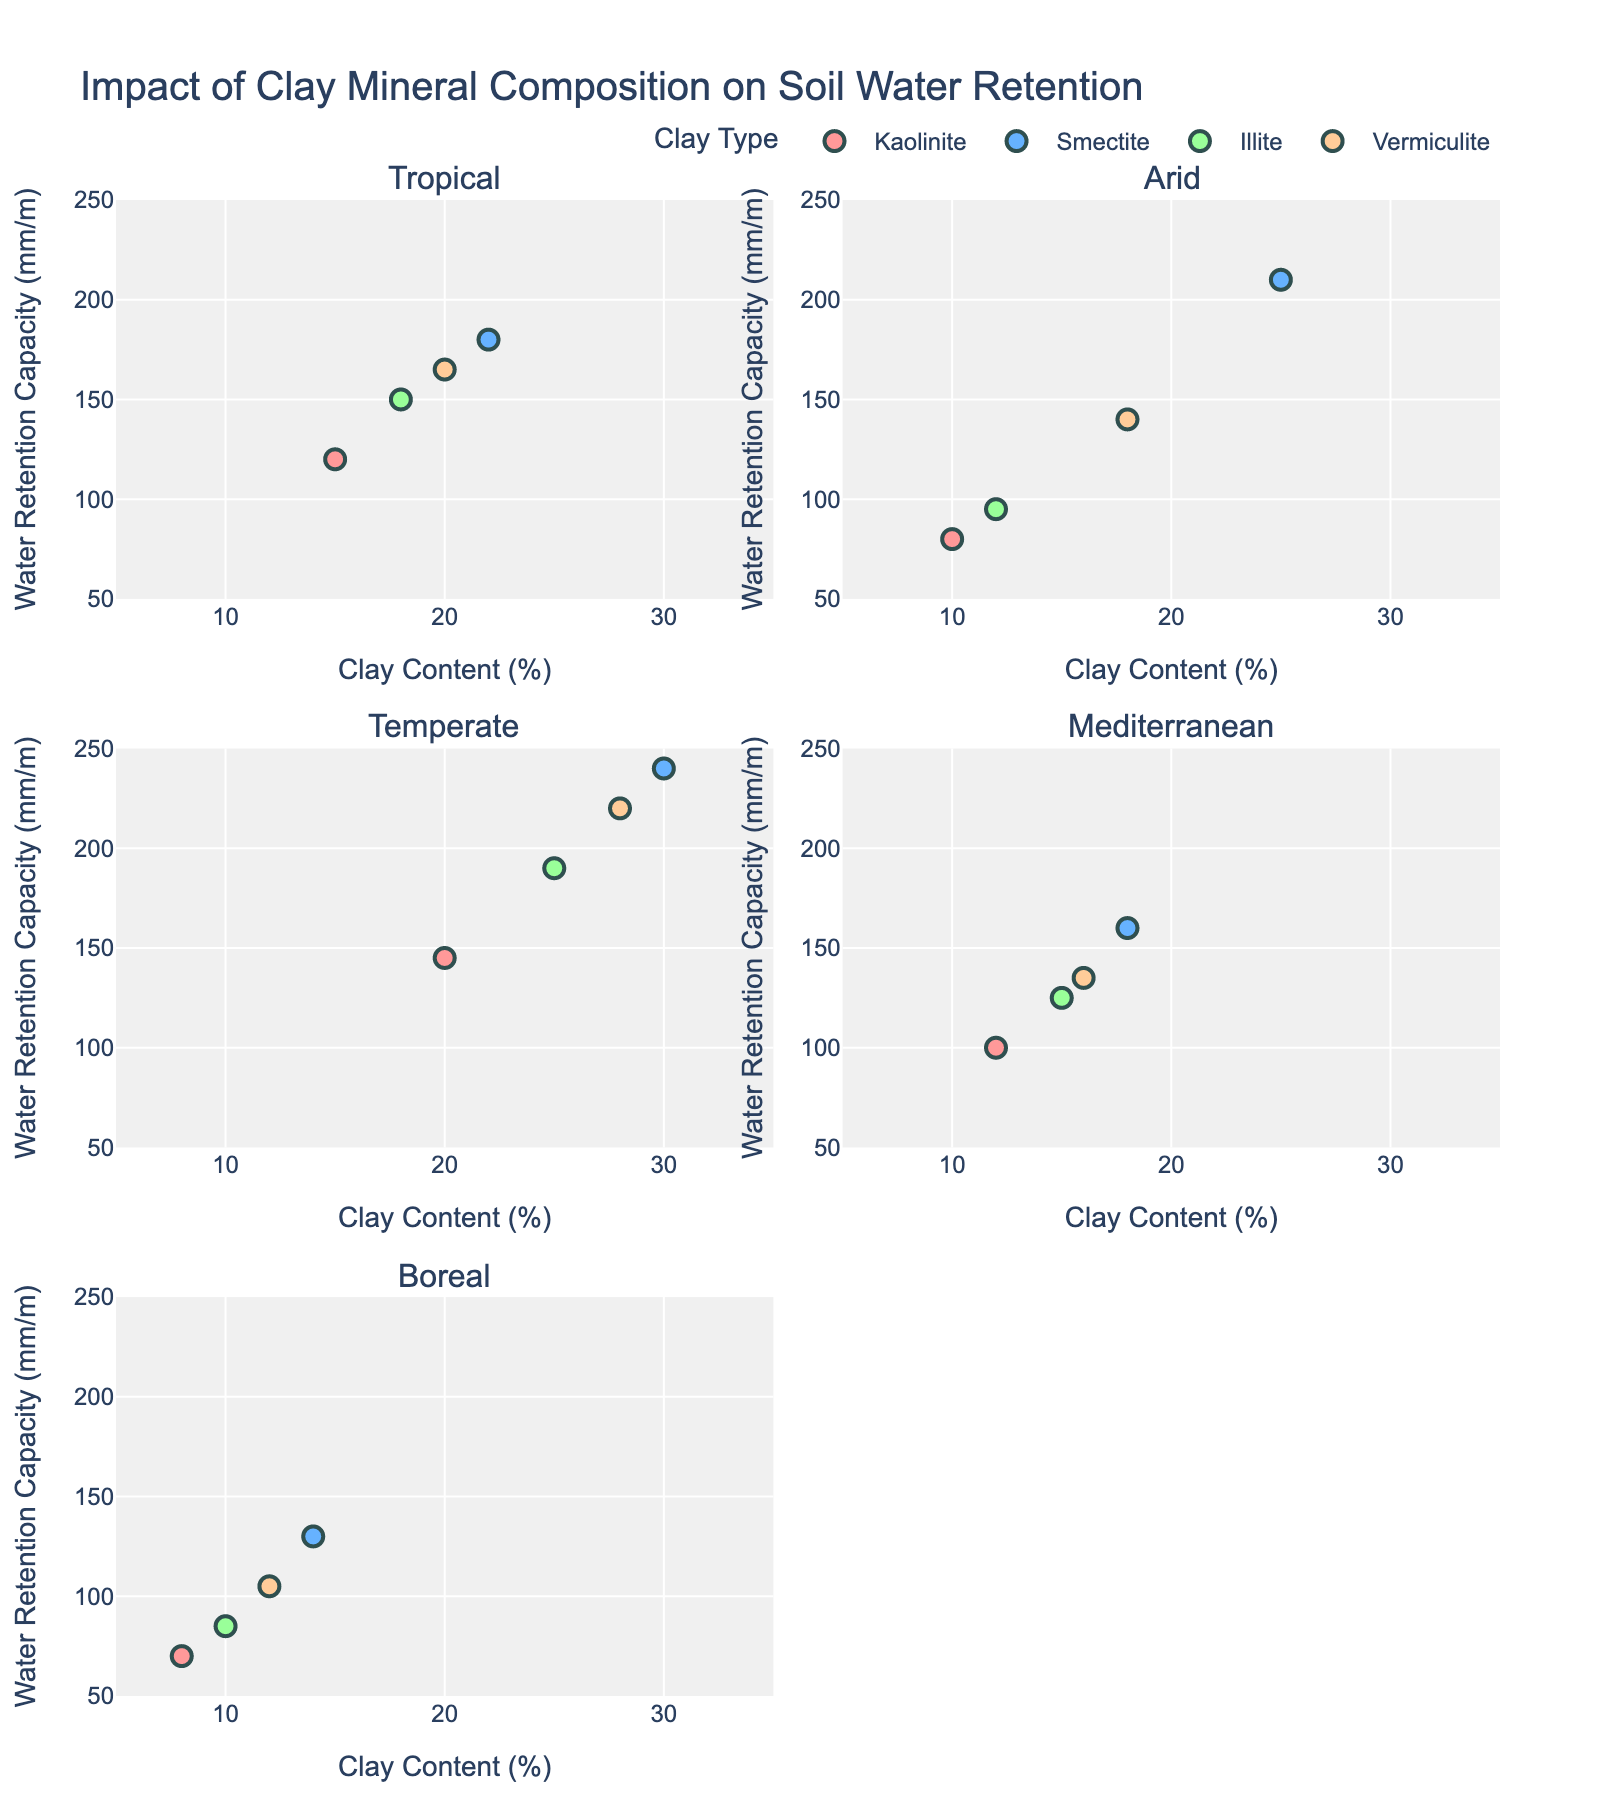What is the title of the figure? The title is written at the top of the figure and summarizes the main topic of the plot. It states "Impact of Clay Mineral Composition on Soil Water Retention."
Answer: Impact of Clay Mineral Composition on Soil Water Retention Which clay type has the highest water retention capacity in the Temperate climate zone? Locate the subplot corresponding to the Temperate climate zone by checking the subplot titles. Observe the scatter plot points, and identify the highest point on the y-axis (Water Retention Capacity) and note its corresponding clay type.
Answer: Smectite How does the water retention capacity for Illite in the Arid zone compare to that in the Tropical zone? Look at the subplots for both the Arid and Tropical zones. Identify the points for Illite in both subplots. Analyze the water retention capacity values (y-axis) for these points. The capacity for Illite in the Arid zone is lower compared to the Tropical zone.
Answer: Lower What is the range of clay content (%) for Kaolinite across all climate zones? Identify all points representing Kaolinite across the subplots. Note the lowest and highest values on the x-axis (Clay Content). The range spans from the minimum to the maximum clay content observed.
Answer: 8-20% Which climate zone has the widest range of water retention capacity for Vermiculite? For each subplot, identify all points representing Vermiculite. Calculate the range by subtracting the minimum y-value from the maximum y-value for Vermiculite in each climate zone. The Temperate zone has the widest range (105).
Answer: Temperate What is the average clay content (%) for Smectite in the Tropical climate zone? Locate the subplot for the Tropical zone and look for points representing Smectite. Sum the clay content values and divide by the number of Smectite points to find the average. The values are 22%, and the average is (22)/1 = 22.
Answer: 22% Which clay type in the Mediterranean climate zone has the lowest water retention capacity? Locate the subplot for the Mediterranean zone. Identify the clay type associated with the lowest point on the y-axis (Water Retention Capacity).
Answer: Kaolinite How does the water retention capacity of Vermiculite in the Boreal zone compare to Illite in the same zone? Look at the Boreal zone subplot. Identify the water retention capacity for both Vermiculite and Illite. Compare their values on the y-axis. Vermiculite has a higher capacity than Illite in the Boreal zone.
Answer: Higher How many climate zones have a water retention capacity for Smectite above 200 mm/m? For each climate zone subplot, locate the points representing Smectite. Count how many subplots have Smectite points with water retention capacity values greater than 200 mm/m. This count is 2 (Arid and Temperate).
Answer: 2 What is the difference in the maximum water retention capacity between Kaolinite and Smectite in the Temperate zone? Locate the Temperate subplot. Identify the maximum water retention values for Kaolinite and Smectite. Subtract the value of Kaolinite from the value of Smectite. The calculation is 240 - 145 = 95.
Answer: 95 